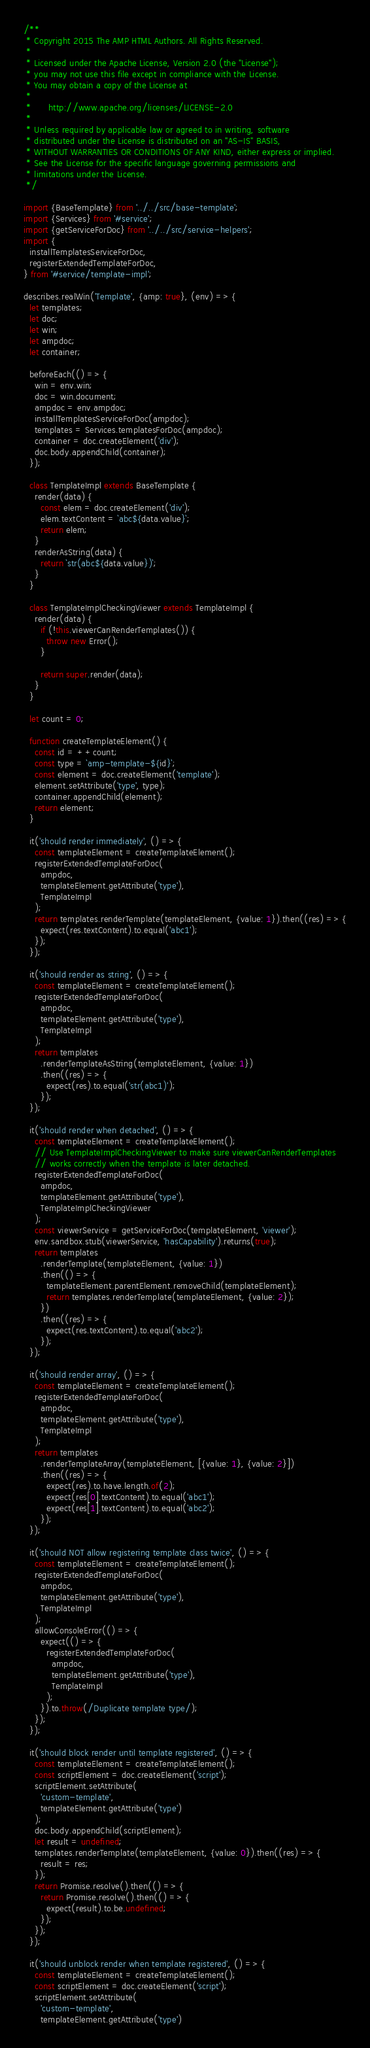Convert code to text. <code><loc_0><loc_0><loc_500><loc_500><_JavaScript_>/**
 * Copyright 2015 The AMP HTML Authors. All Rights Reserved.
 *
 * Licensed under the Apache License, Version 2.0 (the "License");
 * you may not use this file except in compliance with the License.
 * You may obtain a copy of the License at
 *
 *      http://www.apache.org/licenses/LICENSE-2.0
 *
 * Unless required by applicable law or agreed to in writing, software
 * distributed under the License is distributed on an "AS-IS" BASIS,
 * WITHOUT WARRANTIES OR CONDITIONS OF ANY KIND, either express or implied.
 * See the License for the specific language governing permissions and
 * limitations under the License.
 */

import {BaseTemplate} from '../../src/base-template';
import {Services} from '#service';
import {getServiceForDoc} from '../../src/service-helpers';
import {
  installTemplatesServiceForDoc,
  registerExtendedTemplateForDoc,
} from '#service/template-impl';

describes.realWin('Template', {amp: true}, (env) => {
  let templates;
  let doc;
  let win;
  let ampdoc;
  let container;

  beforeEach(() => {
    win = env.win;
    doc = win.document;
    ampdoc = env.ampdoc;
    installTemplatesServiceForDoc(ampdoc);
    templates = Services.templatesForDoc(ampdoc);
    container = doc.createElement('div');
    doc.body.appendChild(container);
  });

  class TemplateImpl extends BaseTemplate {
    render(data) {
      const elem = doc.createElement('div');
      elem.textContent = `abc${data.value}`;
      return elem;
    }
    renderAsString(data) {
      return `str(abc${data.value})`;
    }
  }

  class TemplateImplCheckingViewer extends TemplateImpl {
    render(data) {
      if (!this.viewerCanRenderTemplates()) {
        throw new Error();
      }

      return super.render(data);
    }
  }

  let count = 0;

  function createTemplateElement() {
    const id = ++count;
    const type = `amp-template-${id}`;
    const element = doc.createElement('template');
    element.setAttribute('type', type);
    container.appendChild(element);
    return element;
  }

  it('should render immediately', () => {
    const templateElement = createTemplateElement();
    registerExtendedTemplateForDoc(
      ampdoc,
      templateElement.getAttribute('type'),
      TemplateImpl
    );
    return templates.renderTemplate(templateElement, {value: 1}).then((res) => {
      expect(res.textContent).to.equal('abc1');
    });
  });

  it('should render as string', () => {
    const templateElement = createTemplateElement();
    registerExtendedTemplateForDoc(
      ampdoc,
      templateElement.getAttribute('type'),
      TemplateImpl
    );
    return templates
      .renderTemplateAsString(templateElement, {value: 1})
      .then((res) => {
        expect(res).to.equal('str(abc1)');
      });
  });

  it('should render when detached', () => {
    const templateElement = createTemplateElement();
    // Use TemplateImplCheckingViewer to make sure viewerCanRenderTemplates
    // works correctly when the template is later detached.
    registerExtendedTemplateForDoc(
      ampdoc,
      templateElement.getAttribute('type'),
      TemplateImplCheckingViewer
    );
    const viewerService = getServiceForDoc(templateElement, 'viewer');
    env.sandbox.stub(viewerService, 'hasCapability').returns(true);
    return templates
      .renderTemplate(templateElement, {value: 1})
      .then(() => {
        templateElement.parentElement.removeChild(templateElement);
        return templates.renderTemplate(templateElement, {value: 2});
      })
      .then((res) => {
        expect(res.textContent).to.equal('abc2');
      });
  });

  it('should render array', () => {
    const templateElement = createTemplateElement();
    registerExtendedTemplateForDoc(
      ampdoc,
      templateElement.getAttribute('type'),
      TemplateImpl
    );
    return templates
      .renderTemplateArray(templateElement, [{value: 1}, {value: 2}])
      .then((res) => {
        expect(res).to.have.length.of(2);
        expect(res[0].textContent).to.equal('abc1');
        expect(res[1].textContent).to.equal('abc2');
      });
  });

  it('should NOT allow registering template class twice', () => {
    const templateElement = createTemplateElement();
    registerExtendedTemplateForDoc(
      ampdoc,
      templateElement.getAttribute('type'),
      TemplateImpl
    );
    allowConsoleError(() => {
      expect(() => {
        registerExtendedTemplateForDoc(
          ampdoc,
          templateElement.getAttribute('type'),
          TemplateImpl
        );
      }).to.throw(/Duplicate template type/);
    });
  });

  it('should block render until template registered', () => {
    const templateElement = createTemplateElement();
    const scriptElement = doc.createElement('script');
    scriptElement.setAttribute(
      'custom-template',
      templateElement.getAttribute('type')
    );
    doc.body.appendChild(scriptElement);
    let result = undefined;
    templates.renderTemplate(templateElement, {value: 0}).then((res) => {
      result = res;
    });
    return Promise.resolve().then(() => {
      return Promise.resolve().then(() => {
        expect(result).to.be.undefined;
      });
    });
  });

  it('should unblock render when template registered', () => {
    const templateElement = createTemplateElement();
    const scriptElement = doc.createElement('script');
    scriptElement.setAttribute(
      'custom-template',
      templateElement.getAttribute('type')</code> 